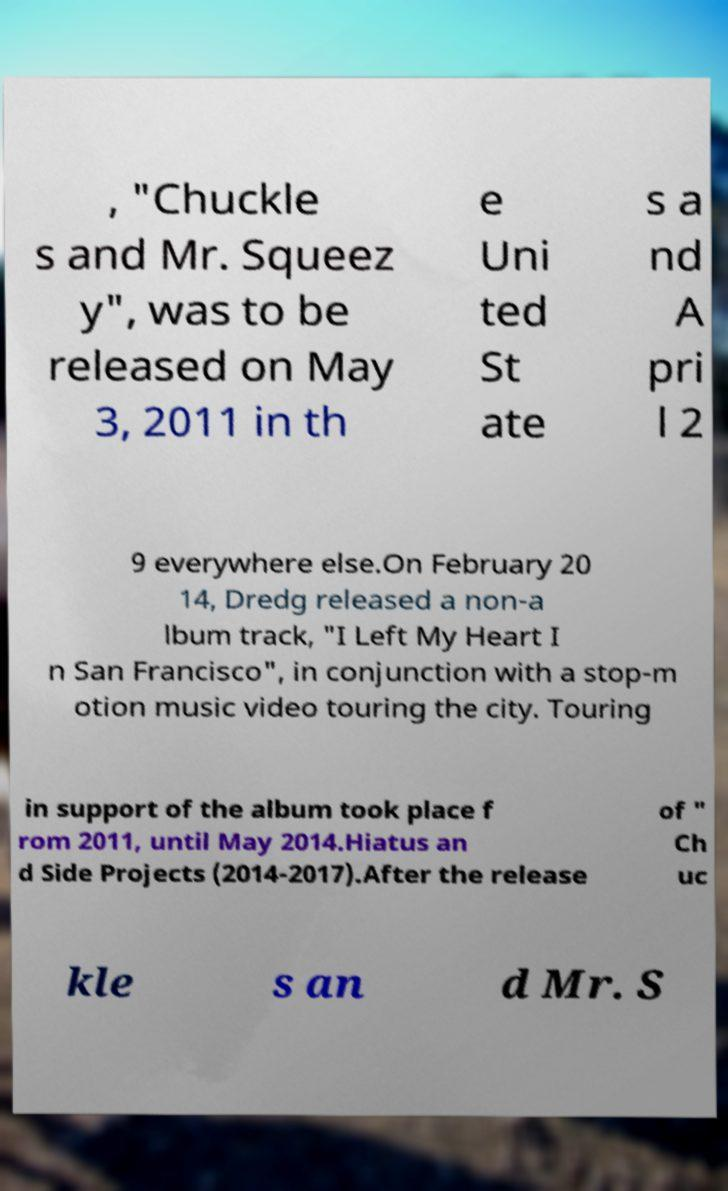Can you accurately transcribe the text from the provided image for me? , "Chuckle s and Mr. Squeez y", was to be released on May 3, 2011 in th e Uni ted St ate s a nd A pri l 2 9 everywhere else.On February 20 14, Dredg released a non-a lbum track, "I Left My Heart I n San Francisco", in conjunction with a stop-m otion music video touring the city. Touring in support of the album took place f rom 2011, until May 2014.Hiatus an d Side Projects (2014-2017).After the release of " Ch uc kle s an d Mr. S 